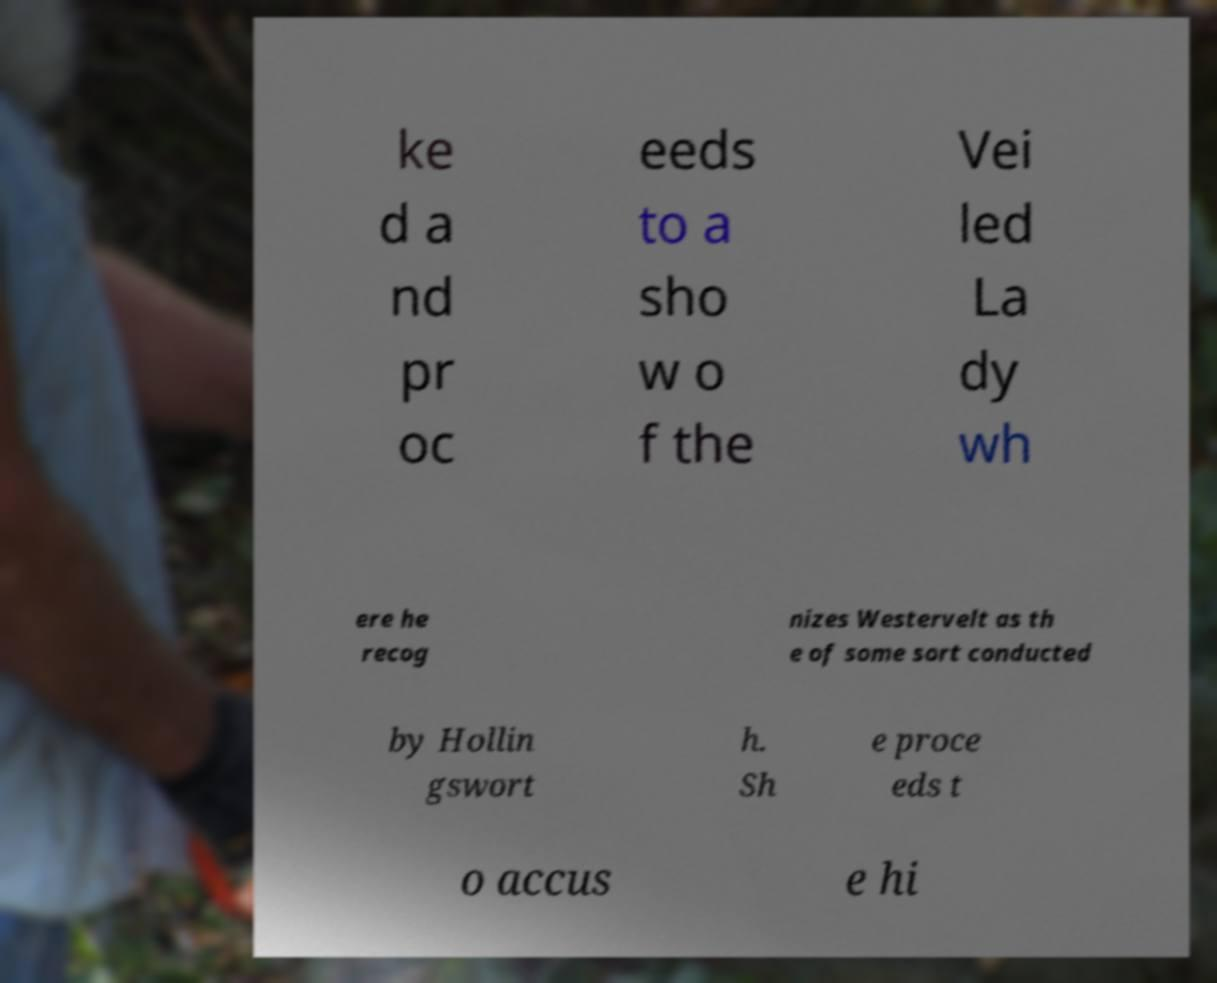Please identify and transcribe the text found in this image. ke d a nd pr oc eeds to a sho w o f the Vei led La dy wh ere he recog nizes Westervelt as th e of some sort conducted by Hollin gswort h. Sh e proce eds t o accus e hi 